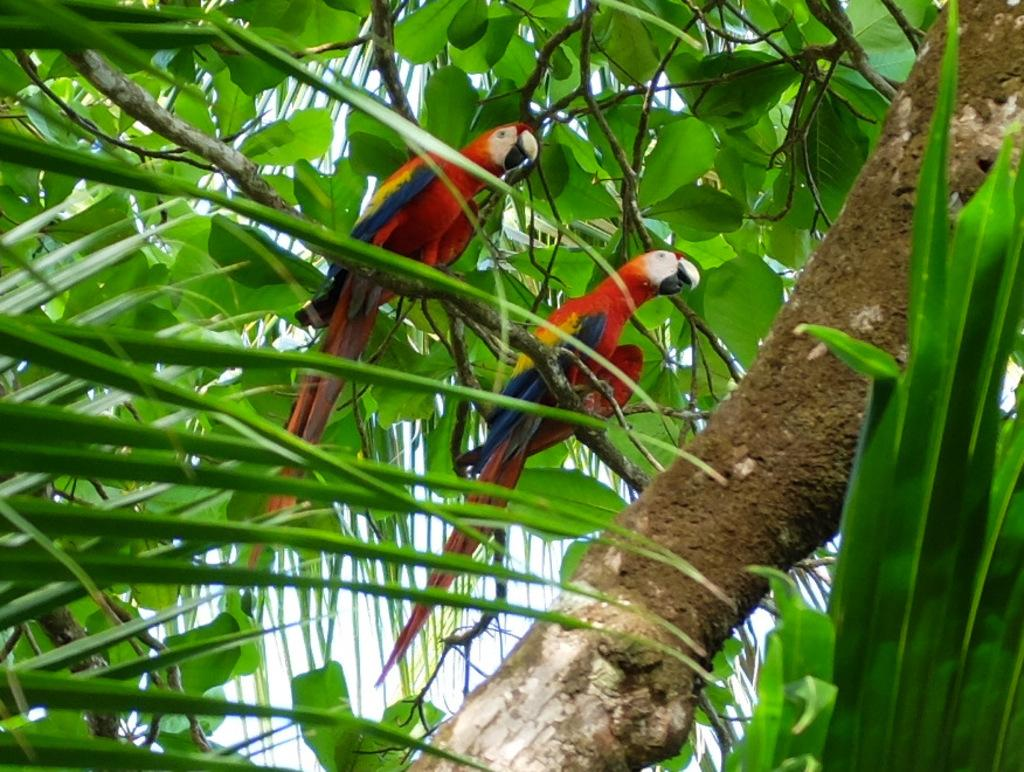What type of plant can be seen in the image? There is a tree in the image. What animals are present in the image? There are birds in the image. What part of the tree is visible in the image? There are leaves in the image. What type of quiver can be seen hanging from the tree in the image? There is no quiver present in the image; it features a tree with birds and leaves. How does the beef affect the flight of the birds in the image? There is no beef present in the image, and therefore it cannot affect the flight of the birds. 